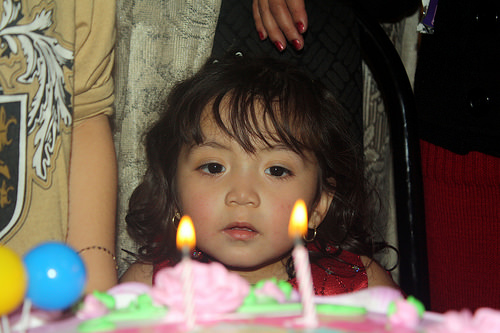<image>
Can you confirm if the candle is on the cake? Yes. Looking at the image, I can see the candle is positioned on top of the cake, with the cake providing support. 